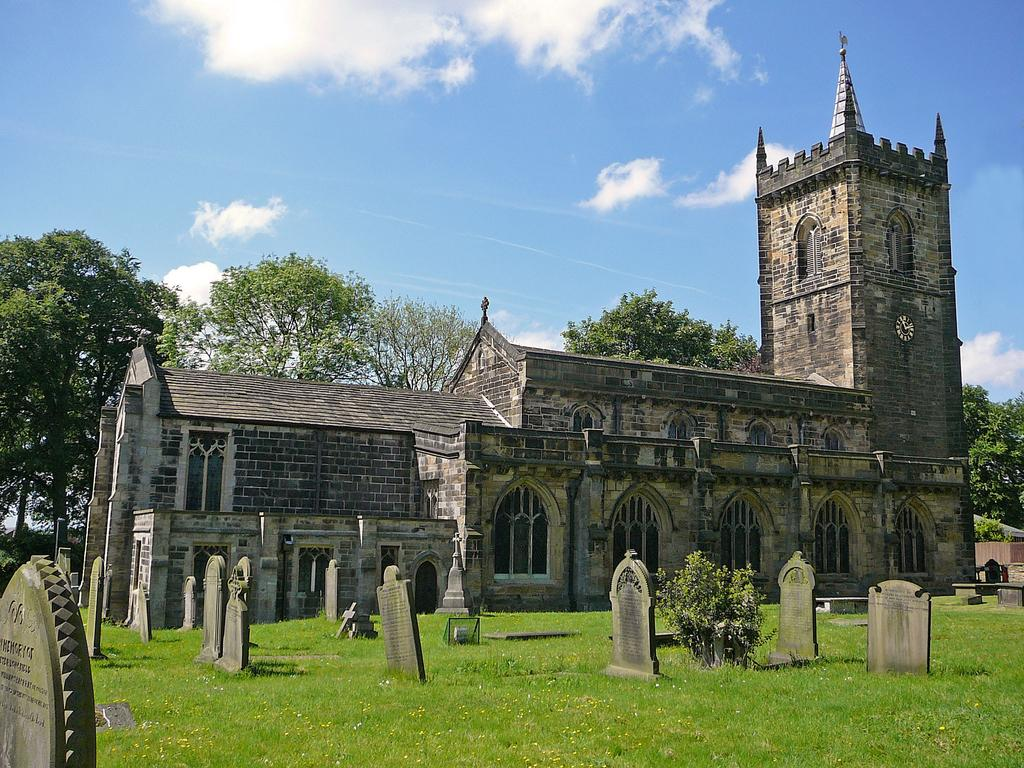What type of structure is visible in the image? There is a building in the image. What is located in front of the building? There is a graveyard in front of the building. What can be seen in the background of the image? There are trees and the sky visible in the background of the image. How many horses are present in the image? There are no horses visible in the image. What word is written on the building in the image? There is no word visible on the building in the image. 